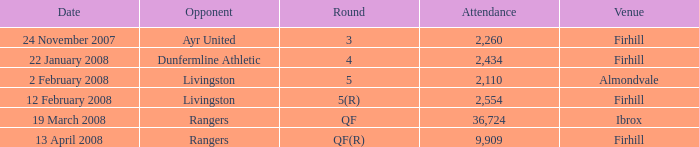What day was the game held at Firhill against AYR United? 24 November 2007. 